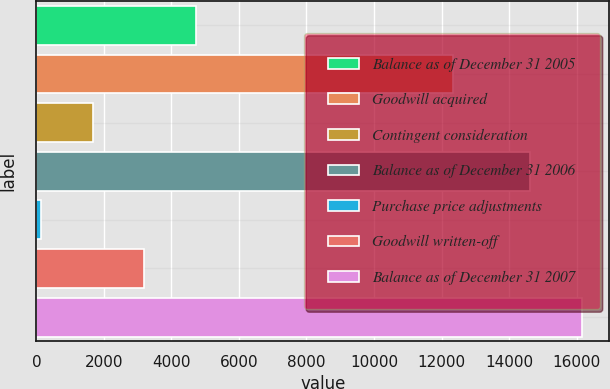Convert chart to OTSL. <chart><loc_0><loc_0><loc_500><loc_500><bar_chart><fcel>Balance as of December 31 2005<fcel>Goodwill acquired<fcel>Contingent consideration<fcel>Balance as of December 31 2006<fcel>Purchase price adjustments<fcel>Goodwill written-off<fcel>Balance as of December 31 2007<nl><fcel>4724.2<fcel>12354<fcel>1669.4<fcel>14628<fcel>142<fcel>3196.8<fcel>16155.4<nl></chart> 